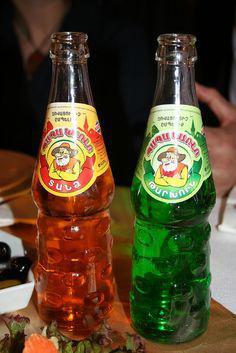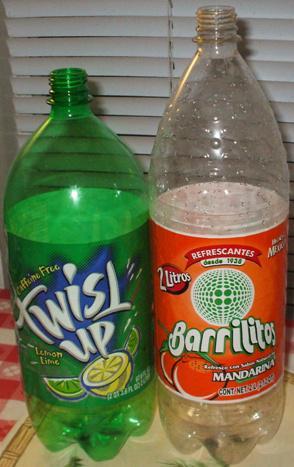The first image is the image on the left, the second image is the image on the right. Evaluate the accuracy of this statement regarding the images: "In one image the bottles are made of glass and the other has plastic bottles". Is it true? Answer yes or no. Yes. The first image is the image on the left, the second image is the image on the right. Evaluate the accuracy of this statement regarding the images: "The right image includes at least three upright bottles with multicolored candies on the surface next to them.". Is it true? Answer yes or no. No. 